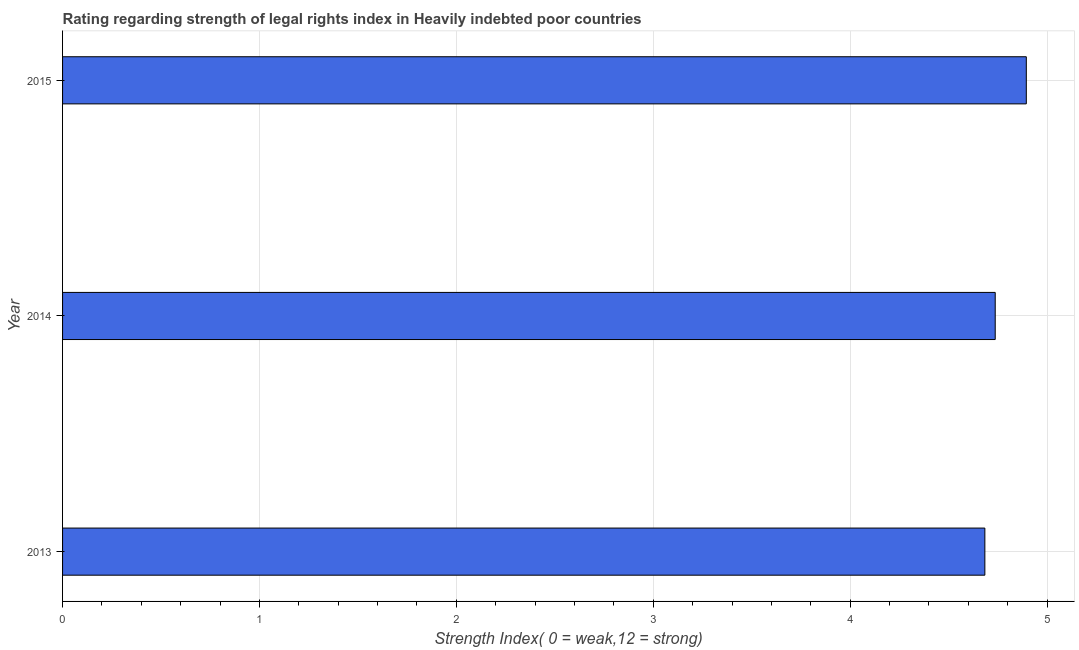Does the graph contain grids?
Your response must be concise. Yes. What is the title of the graph?
Offer a terse response. Rating regarding strength of legal rights index in Heavily indebted poor countries. What is the label or title of the X-axis?
Provide a short and direct response. Strength Index( 0 = weak,12 = strong). What is the label or title of the Y-axis?
Offer a terse response. Year. What is the strength of legal rights index in 2015?
Offer a very short reply. 4.89. Across all years, what is the maximum strength of legal rights index?
Provide a short and direct response. 4.89. Across all years, what is the minimum strength of legal rights index?
Your answer should be compact. 4.68. In which year was the strength of legal rights index maximum?
Offer a very short reply. 2015. In which year was the strength of legal rights index minimum?
Offer a terse response. 2013. What is the sum of the strength of legal rights index?
Ensure brevity in your answer.  14.32. What is the difference between the strength of legal rights index in 2014 and 2015?
Offer a terse response. -0.16. What is the average strength of legal rights index per year?
Offer a terse response. 4.77. What is the median strength of legal rights index?
Offer a very short reply. 4.74. Do a majority of the years between 2015 and 2013 (inclusive) have strength of legal rights index greater than 4 ?
Your answer should be very brief. Yes. Is the difference between the strength of legal rights index in 2013 and 2015 greater than the difference between any two years?
Make the answer very short. Yes. What is the difference between the highest and the second highest strength of legal rights index?
Ensure brevity in your answer.  0.16. What is the difference between the highest and the lowest strength of legal rights index?
Offer a terse response. 0.21. Are all the bars in the graph horizontal?
Your answer should be compact. Yes. What is the difference between two consecutive major ticks on the X-axis?
Offer a terse response. 1. Are the values on the major ticks of X-axis written in scientific E-notation?
Provide a short and direct response. No. What is the Strength Index( 0 = weak,12 = strong) of 2013?
Make the answer very short. 4.68. What is the Strength Index( 0 = weak,12 = strong) of 2014?
Ensure brevity in your answer.  4.74. What is the Strength Index( 0 = weak,12 = strong) of 2015?
Offer a terse response. 4.89. What is the difference between the Strength Index( 0 = weak,12 = strong) in 2013 and 2014?
Your answer should be compact. -0.05. What is the difference between the Strength Index( 0 = weak,12 = strong) in 2013 and 2015?
Offer a very short reply. -0.21. What is the difference between the Strength Index( 0 = weak,12 = strong) in 2014 and 2015?
Your response must be concise. -0.16. What is the ratio of the Strength Index( 0 = weak,12 = strong) in 2013 to that in 2015?
Keep it short and to the point. 0.96. 